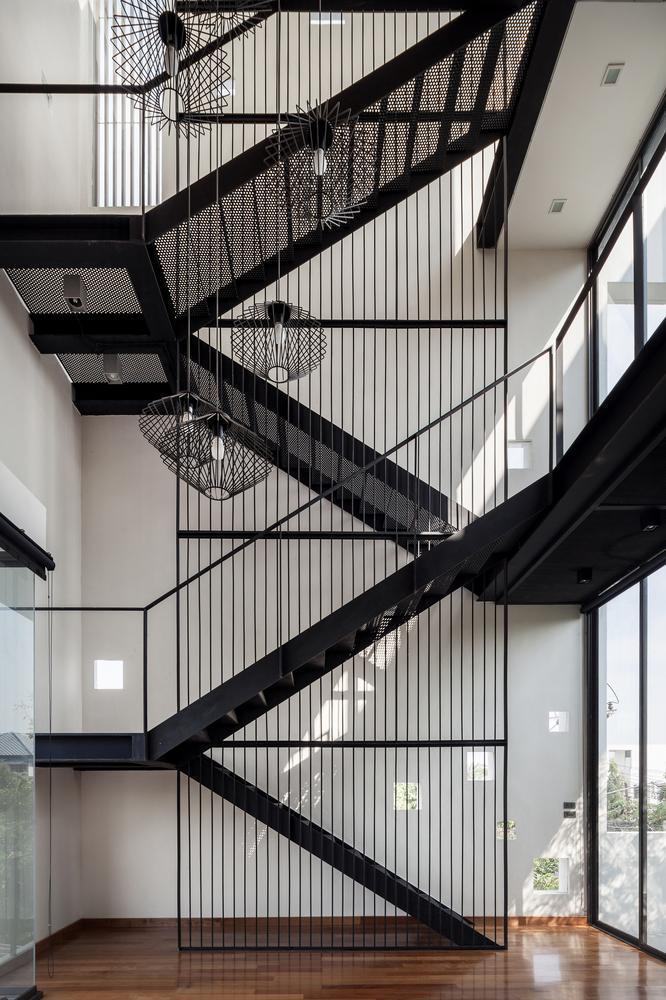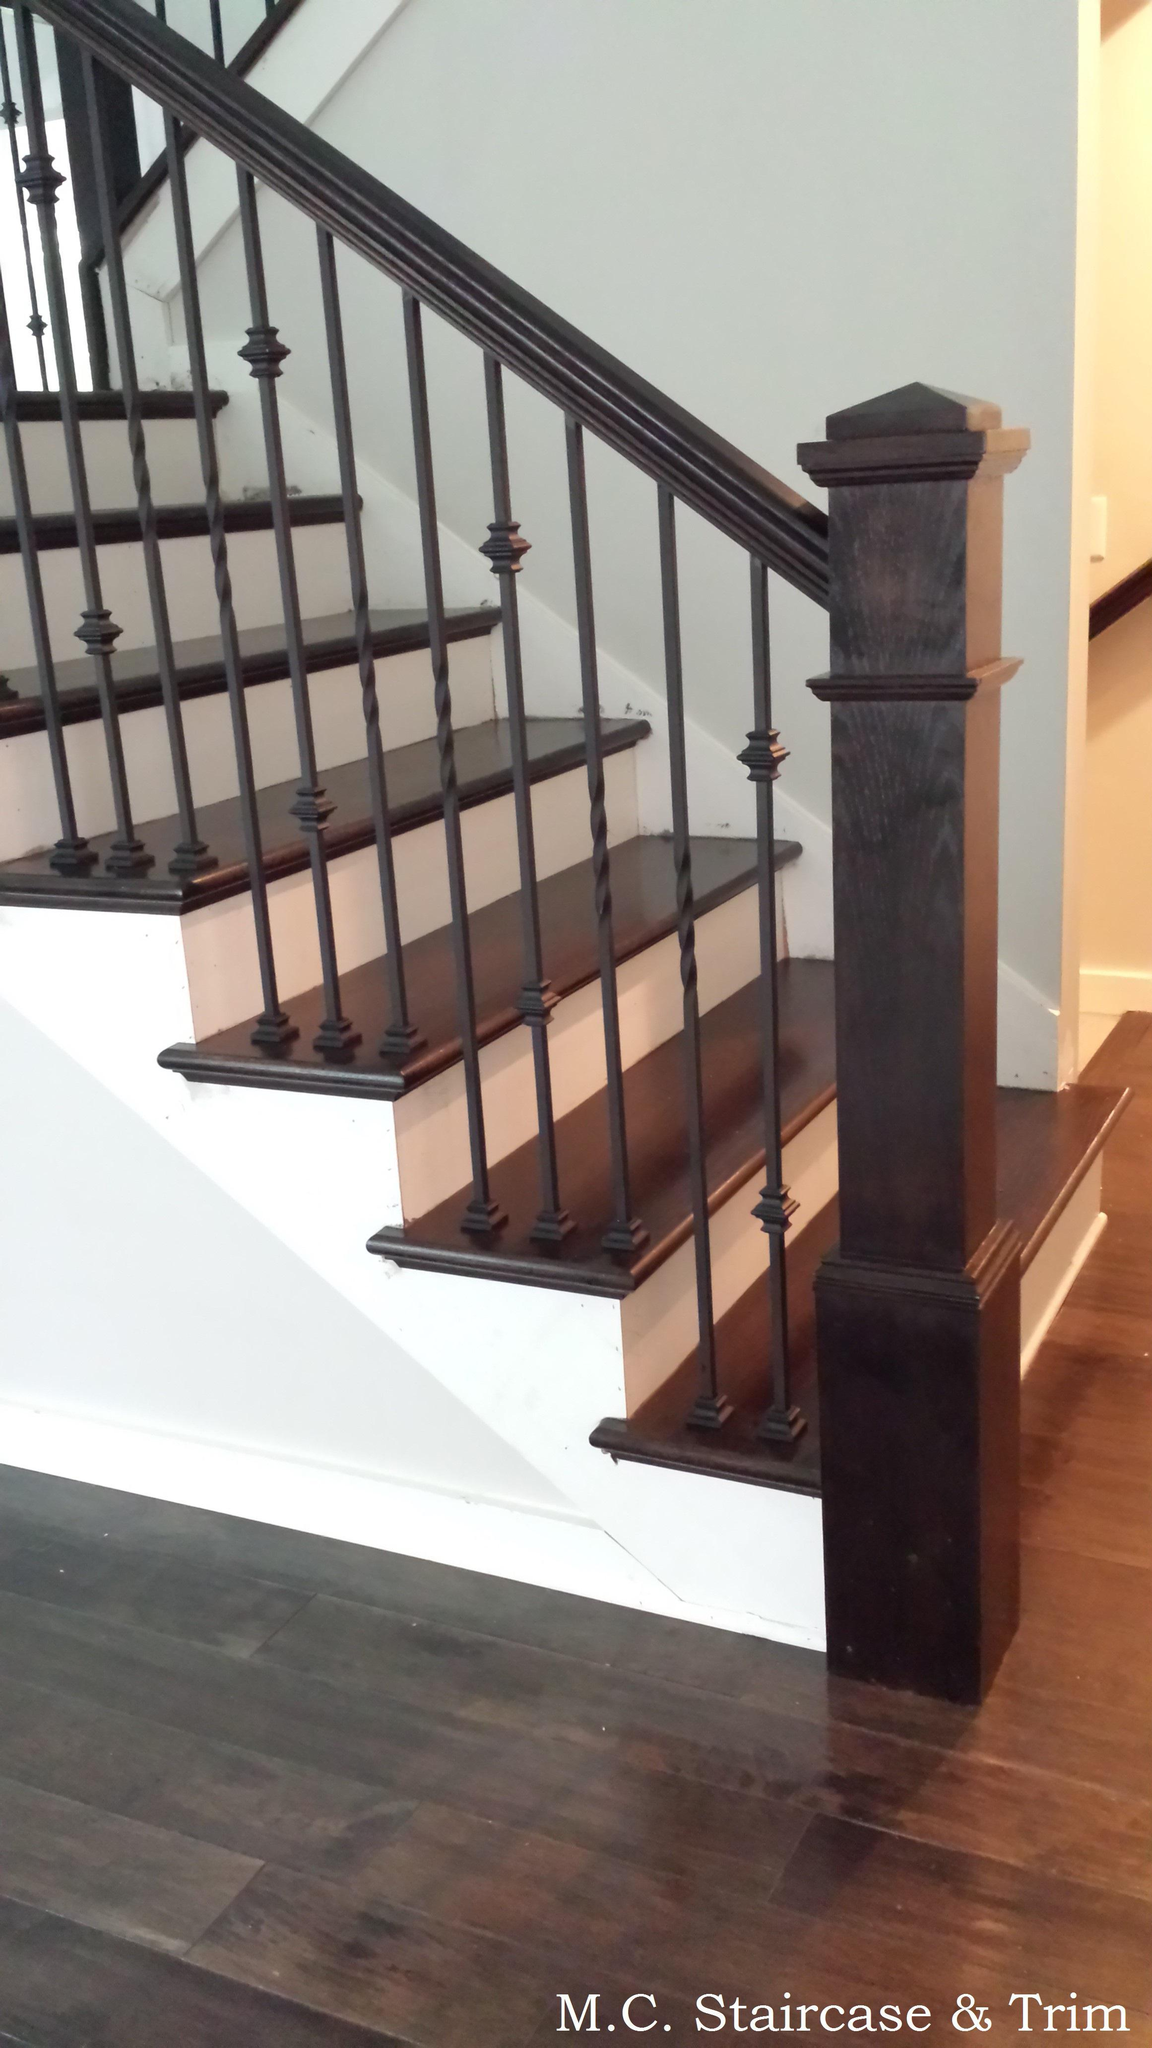The first image is the image on the left, the second image is the image on the right. Considering the images on both sides, is "One image in the pair shows carpeted stairs and the other shows uncarpeted stairs." valid? Answer yes or no. No. The first image is the image on the left, the second image is the image on the right. Considering the images on both sides, is "All the vertical stairway railings are black." valid? Answer yes or no. Yes. 